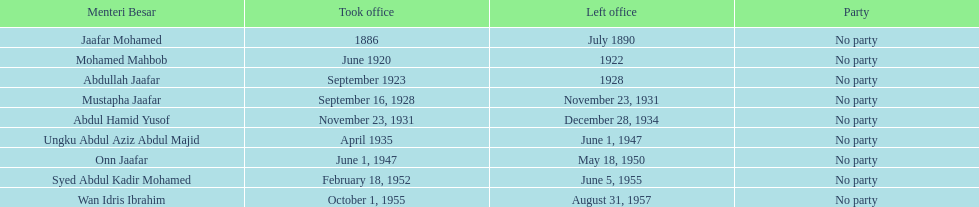Who are all of the menteri besars? Jaafar Mohamed, Mohamed Mahbob, Abdullah Jaafar, Mustapha Jaafar, Abdul Hamid Yusof, Ungku Abdul Aziz Abdul Majid, Onn Jaafar, Syed Abdul Kadir Mohamed, Wan Idris Ibrahim. When did each take office? 1886, June 1920, September 1923, September 16, 1928, November 23, 1931, April 1935, June 1, 1947, February 18, 1952, October 1, 1955. When did they leave? July 1890, 1922, 1928, November 23, 1931, December 28, 1934, June 1, 1947, May 18, 1950, June 5, 1955, August 31, 1957. And which spent the most time in office? Ungku Abdul Aziz Abdul Majid. 